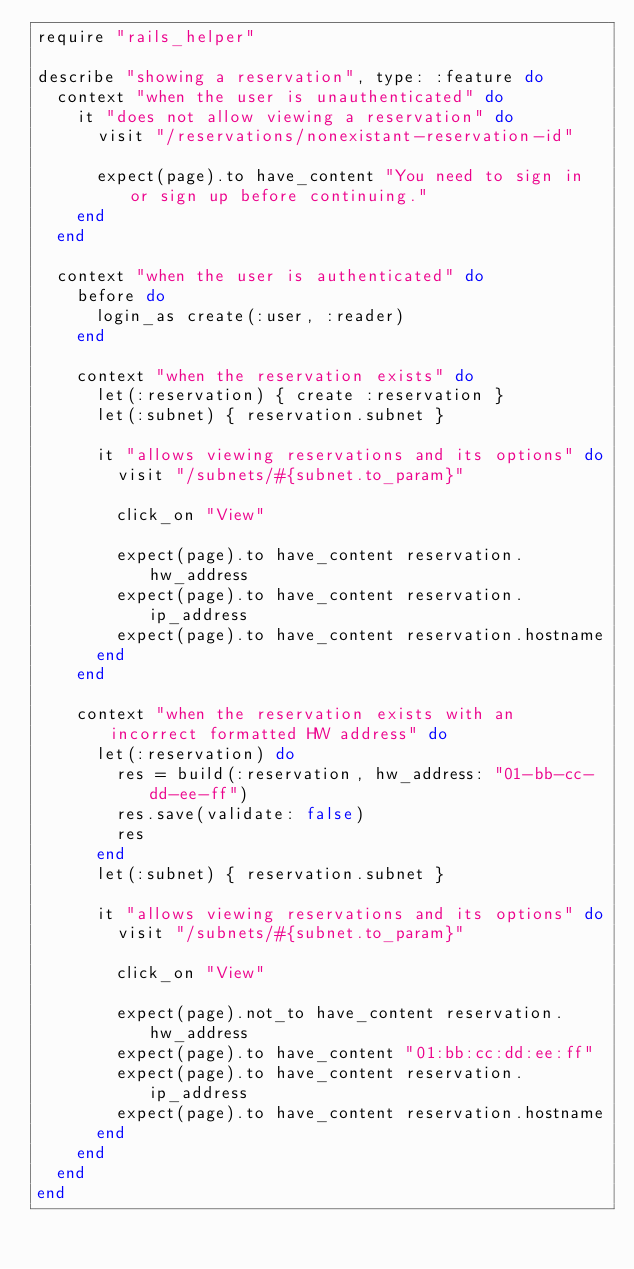Convert code to text. <code><loc_0><loc_0><loc_500><loc_500><_Ruby_>require "rails_helper"

describe "showing a reservation", type: :feature do
  context "when the user is unauthenticated" do
    it "does not allow viewing a reservation" do
      visit "/reservations/nonexistant-reservation-id"

      expect(page).to have_content "You need to sign in or sign up before continuing."
    end
  end

  context "when the user is authenticated" do
    before do
      login_as create(:user, :reader)
    end

    context "when the reservation exists" do
      let(:reservation) { create :reservation }
      let(:subnet) { reservation.subnet }

      it "allows viewing reservations and its options" do
        visit "/subnets/#{subnet.to_param}"

        click_on "View"

        expect(page).to have_content reservation.hw_address
        expect(page).to have_content reservation.ip_address
        expect(page).to have_content reservation.hostname
      end
    end

    context "when the reservation exists with an incorrect formatted HW address" do
      let(:reservation) do
        res = build(:reservation, hw_address: "01-bb-cc-dd-ee-ff")
        res.save(validate: false)
        res
      end
      let(:subnet) { reservation.subnet }

      it "allows viewing reservations and its options" do
        visit "/subnets/#{subnet.to_param}"

        click_on "View"

        expect(page).not_to have_content reservation.hw_address
        expect(page).to have_content "01:bb:cc:dd:ee:ff"
        expect(page).to have_content reservation.ip_address
        expect(page).to have_content reservation.hostname
      end
    end
  end
end
</code> 